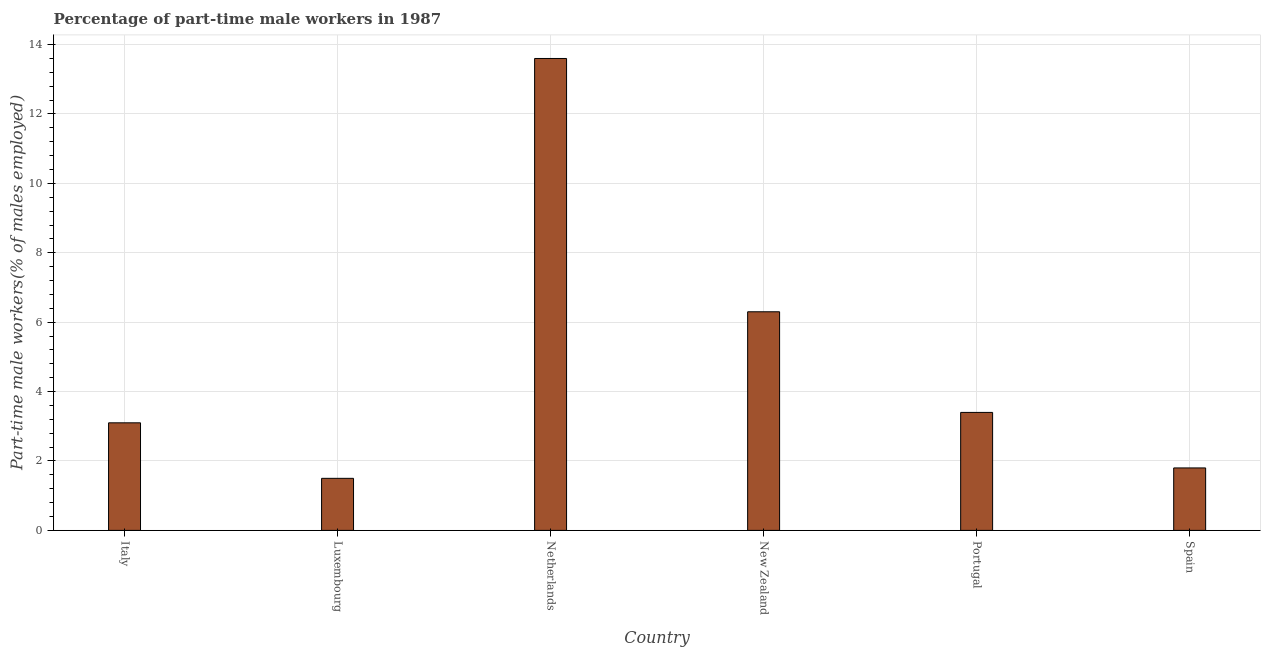Does the graph contain any zero values?
Offer a terse response. No. What is the title of the graph?
Keep it short and to the point. Percentage of part-time male workers in 1987. What is the label or title of the X-axis?
Make the answer very short. Country. What is the label or title of the Y-axis?
Your answer should be very brief. Part-time male workers(% of males employed). What is the percentage of part-time male workers in New Zealand?
Your answer should be very brief. 6.3. Across all countries, what is the maximum percentage of part-time male workers?
Keep it short and to the point. 13.6. In which country was the percentage of part-time male workers maximum?
Ensure brevity in your answer.  Netherlands. In which country was the percentage of part-time male workers minimum?
Provide a short and direct response. Luxembourg. What is the sum of the percentage of part-time male workers?
Offer a very short reply. 29.7. What is the difference between the percentage of part-time male workers in Netherlands and Portugal?
Give a very brief answer. 10.2. What is the average percentage of part-time male workers per country?
Give a very brief answer. 4.95. In how many countries, is the percentage of part-time male workers greater than 1.6 %?
Your answer should be very brief. 5. What is the ratio of the percentage of part-time male workers in Netherlands to that in Spain?
Ensure brevity in your answer.  7.56. In how many countries, is the percentage of part-time male workers greater than the average percentage of part-time male workers taken over all countries?
Your answer should be compact. 2. Are all the bars in the graph horizontal?
Keep it short and to the point. No. How many countries are there in the graph?
Your answer should be compact. 6. What is the difference between two consecutive major ticks on the Y-axis?
Offer a terse response. 2. What is the Part-time male workers(% of males employed) of Italy?
Offer a terse response. 3.1. What is the Part-time male workers(% of males employed) in Luxembourg?
Your answer should be very brief. 1.5. What is the Part-time male workers(% of males employed) of Netherlands?
Your response must be concise. 13.6. What is the Part-time male workers(% of males employed) in New Zealand?
Your answer should be compact. 6.3. What is the Part-time male workers(% of males employed) of Portugal?
Your answer should be compact. 3.4. What is the Part-time male workers(% of males employed) of Spain?
Keep it short and to the point. 1.8. What is the difference between the Part-time male workers(% of males employed) in Italy and Luxembourg?
Offer a terse response. 1.6. What is the difference between the Part-time male workers(% of males employed) in Italy and Netherlands?
Ensure brevity in your answer.  -10.5. What is the difference between the Part-time male workers(% of males employed) in Italy and New Zealand?
Make the answer very short. -3.2. What is the difference between the Part-time male workers(% of males employed) in Italy and Portugal?
Make the answer very short. -0.3. What is the difference between the Part-time male workers(% of males employed) in Luxembourg and New Zealand?
Give a very brief answer. -4.8. What is the difference between the Part-time male workers(% of males employed) in Netherlands and New Zealand?
Your answer should be very brief. 7.3. What is the difference between the Part-time male workers(% of males employed) in Netherlands and Portugal?
Your answer should be very brief. 10.2. What is the ratio of the Part-time male workers(% of males employed) in Italy to that in Luxembourg?
Give a very brief answer. 2.07. What is the ratio of the Part-time male workers(% of males employed) in Italy to that in Netherlands?
Your answer should be very brief. 0.23. What is the ratio of the Part-time male workers(% of males employed) in Italy to that in New Zealand?
Provide a short and direct response. 0.49. What is the ratio of the Part-time male workers(% of males employed) in Italy to that in Portugal?
Your answer should be very brief. 0.91. What is the ratio of the Part-time male workers(% of males employed) in Italy to that in Spain?
Provide a succinct answer. 1.72. What is the ratio of the Part-time male workers(% of males employed) in Luxembourg to that in Netherlands?
Offer a very short reply. 0.11. What is the ratio of the Part-time male workers(% of males employed) in Luxembourg to that in New Zealand?
Your response must be concise. 0.24. What is the ratio of the Part-time male workers(% of males employed) in Luxembourg to that in Portugal?
Your response must be concise. 0.44. What is the ratio of the Part-time male workers(% of males employed) in Luxembourg to that in Spain?
Ensure brevity in your answer.  0.83. What is the ratio of the Part-time male workers(% of males employed) in Netherlands to that in New Zealand?
Ensure brevity in your answer.  2.16. What is the ratio of the Part-time male workers(% of males employed) in Netherlands to that in Portugal?
Your response must be concise. 4. What is the ratio of the Part-time male workers(% of males employed) in Netherlands to that in Spain?
Your answer should be compact. 7.56. What is the ratio of the Part-time male workers(% of males employed) in New Zealand to that in Portugal?
Your answer should be very brief. 1.85. What is the ratio of the Part-time male workers(% of males employed) in Portugal to that in Spain?
Offer a very short reply. 1.89. 